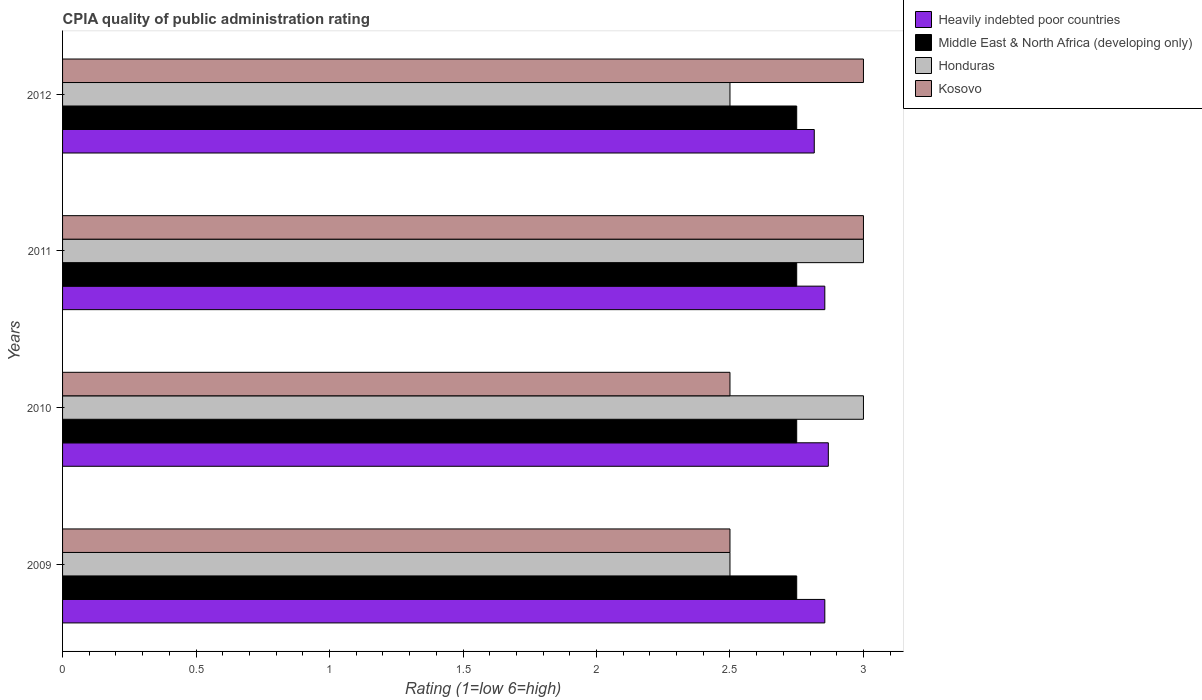What is the label of the 3rd group of bars from the top?
Provide a succinct answer. 2010. In how many cases, is the number of bars for a given year not equal to the number of legend labels?
Offer a terse response. 0. What is the CPIA rating in Kosovo in 2011?
Offer a terse response. 3. Across all years, what is the maximum CPIA rating in Heavily indebted poor countries?
Provide a succinct answer. 2.87. Across all years, what is the minimum CPIA rating in Heavily indebted poor countries?
Keep it short and to the point. 2.82. In which year was the CPIA rating in Honduras maximum?
Make the answer very short. 2010. In which year was the CPIA rating in Heavily indebted poor countries minimum?
Give a very brief answer. 2012. What is the total CPIA rating in Heavily indebted poor countries in the graph?
Ensure brevity in your answer.  11.39. What is the difference between the CPIA rating in Honduras in 2010 and the CPIA rating in Heavily indebted poor countries in 2012?
Your response must be concise. 0.18. What is the average CPIA rating in Heavily indebted poor countries per year?
Make the answer very short. 2.85. In the year 2012, what is the difference between the CPIA rating in Heavily indebted poor countries and CPIA rating in Kosovo?
Your answer should be very brief. -0.18. In how many years, is the CPIA rating in Kosovo greater than 1.6 ?
Offer a terse response. 4. What is the ratio of the CPIA rating in Middle East & North Africa (developing only) in 2009 to that in 2012?
Provide a succinct answer. 1. Is the CPIA rating in Middle East & North Africa (developing only) in 2009 less than that in 2011?
Give a very brief answer. No. What is the difference between the highest and the second highest CPIA rating in Honduras?
Provide a short and direct response. 0. What is the difference between the highest and the lowest CPIA rating in Middle East & North Africa (developing only)?
Offer a terse response. 0. What does the 4th bar from the top in 2010 represents?
Offer a terse response. Heavily indebted poor countries. What does the 3rd bar from the bottom in 2012 represents?
Provide a short and direct response. Honduras. Is it the case that in every year, the sum of the CPIA rating in Middle East & North Africa (developing only) and CPIA rating in Honduras is greater than the CPIA rating in Heavily indebted poor countries?
Make the answer very short. Yes. How many bars are there?
Provide a succinct answer. 16. Are all the bars in the graph horizontal?
Your answer should be very brief. Yes. Are the values on the major ticks of X-axis written in scientific E-notation?
Keep it short and to the point. No. Does the graph contain any zero values?
Make the answer very short. No. Does the graph contain grids?
Offer a terse response. No. How are the legend labels stacked?
Give a very brief answer. Vertical. What is the title of the graph?
Your answer should be very brief. CPIA quality of public administration rating. Does "Timor-Leste" appear as one of the legend labels in the graph?
Keep it short and to the point. No. What is the label or title of the X-axis?
Provide a short and direct response. Rating (1=low 6=high). What is the label or title of the Y-axis?
Provide a short and direct response. Years. What is the Rating (1=low 6=high) of Heavily indebted poor countries in 2009?
Provide a short and direct response. 2.86. What is the Rating (1=low 6=high) of Middle East & North Africa (developing only) in 2009?
Provide a succinct answer. 2.75. What is the Rating (1=low 6=high) of Honduras in 2009?
Give a very brief answer. 2.5. What is the Rating (1=low 6=high) of Kosovo in 2009?
Keep it short and to the point. 2.5. What is the Rating (1=low 6=high) of Heavily indebted poor countries in 2010?
Make the answer very short. 2.87. What is the Rating (1=low 6=high) of Middle East & North Africa (developing only) in 2010?
Offer a terse response. 2.75. What is the Rating (1=low 6=high) in Honduras in 2010?
Your answer should be very brief. 3. What is the Rating (1=low 6=high) in Kosovo in 2010?
Your answer should be very brief. 2.5. What is the Rating (1=low 6=high) in Heavily indebted poor countries in 2011?
Keep it short and to the point. 2.86. What is the Rating (1=low 6=high) in Middle East & North Africa (developing only) in 2011?
Make the answer very short. 2.75. What is the Rating (1=low 6=high) of Kosovo in 2011?
Give a very brief answer. 3. What is the Rating (1=low 6=high) in Heavily indebted poor countries in 2012?
Your response must be concise. 2.82. What is the Rating (1=low 6=high) in Middle East & North Africa (developing only) in 2012?
Ensure brevity in your answer.  2.75. What is the Rating (1=low 6=high) of Kosovo in 2012?
Give a very brief answer. 3. Across all years, what is the maximum Rating (1=low 6=high) in Heavily indebted poor countries?
Provide a short and direct response. 2.87. Across all years, what is the maximum Rating (1=low 6=high) in Middle East & North Africa (developing only)?
Provide a short and direct response. 2.75. Across all years, what is the minimum Rating (1=low 6=high) in Heavily indebted poor countries?
Your answer should be compact. 2.82. Across all years, what is the minimum Rating (1=low 6=high) of Middle East & North Africa (developing only)?
Provide a succinct answer. 2.75. Across all years, what is the minimum Rating (1=low 6=high) in Honduras?
Your response must be concise. 2.5. What is the total Rating (1=low 6=high) of Heavily indebted poor countries in the graph?
Your answer should be very brief. 11.39. What is the total Rating (1=low 6=high) of Middle East & North Africa (developing only) in the graph?
Your answer should be compact. 11. What is the total Rating (1=low 6=high) of Honduras in the graph?
Provide a short and direct response. 11. What is the total Rating (1=low 6=high) in Kosovo in the graph?
Offer a terse response. 11. What is the difference between the Rating (1=low 6=high) of Heavily indebted poor countries in 2009 and that in 2010?
Your answer should be compact. -0.01. What is the difference between the Rating (1=low 6=high) of Middle East & North Africa (developing only) in 2009 and that in 2010?
Offer a terse response. 0. What is the difference between the Rating (1=low 6=high) of Honduras in 2009 and that in 2010?
Make the answer very short. -0.5. What is the difference between the Rating (1=low 6=high) in Kosovo in 2009 and that in 2010?
Provide a short and direct response. 0. What is the difference between the Rating (1=low 6=high) of Heavily indebted poor countries in 2009 and that in 2011?
Provide a succinct answer. 0. What is the difference between the Rating (1=low 6=high) in Middle East & North Africa (developing only) in 2009 and that in 2011?
Ensure brevity in your answer.  0. What is the difference between the Rating (1=low 6=high) of Honduras in 2009 and that in 2011?
Provide a succinct answer. -0.5. What is the difference between the Rating (1=low 6=high) of Heavily indebted poor countries in 2009 and that in 2012?
Ensure brevity in your answer.  0.04. What is the difference between the Rating (1=low 6=high) in Middle East & North Africa (developing only) in 2009 and that in 2012?
Ensure brevity in your answer.  0. What is the difference between the Rating (1=low 6=high) of Honduras in 2009 and that in 2012?
Your answer should be compact. 0. What is the difference between the Rating (1=low 6=high) in Heavily indebted poor countries in 2010 and that in 2011?
Offer a very short reply. 0.01. What is the difference between the Rating (1=low 6=high) of Middle East & North Africa (developing only) in 2010 and that in 2011?
Your answer should be very brief. 0. What is the difference between the Rating (1=low 6=high) of Honduras in 2010 and that in 2011?
Provide a succinct answer. 0. What is the difference between the Rating (1=low 6=high) of Heavily indebted poor countries in 2010 and that in 2012?
Make the answer very short. 0.05. What is the difference between the Rating (1=low 6=high) in Kosovo in 2010 and that in 2012?
Your response must be concise. -0.5. What is the difference between the Rating (1=low 6=high) in Heavily indebted poor countries in 2011 and that in 2012?
Give a very brief answer. 0.04. What is the difference between the Rating (1=low 6=high) of Kosovo in 2011 and that in 2012?
Give a very brief answer. 0. What is the difference between the Rating (1=low 6=high) of Heavily indebted poor countries in 2009 and the Rating (1=low 6=high) of Middle East & North Africa (developing only) in 2010?
Offer a terse response. 0.11. What is the difference between the Rating (1=low 6=high) of Heavily indebted poor countries in 2009 and the Rating (1=low 6=high) of Honduras in 2010?
Make the answer very short. -0.14. What is the difference between the Rating (1=low 6=high) of Heavily indebted poor countries in 2009 and the Rating (1=low 6=high) of Kosovo in 2010?
Offer a terse response. 0.36. What is the difference between the Rating (1=low 6=high) of Middle East & North Africa (developing only) in 2009 and the Rating (1=low 6=high) of Honduras in 2010?
Your response must be concise. -0.25. What is the difference between the Rating (1=low 6=high) of Middle East & North Africa (developing only) in 2009 and the Rating (1=low 6=high) of Kosovo in 2010?
Make the answer very short. 0.25. What is the difference between the Rating (1=low 6=high) of Honduras in 2009 and the Rating (1=low 6=high) of Kosovo in 2010?
Ensure brevity in your answer.  0. What is the difference between the Rating (1=low 6=high) of Heavily indebted poor countries in 2009 and the Rating (1=low 6=high) of Middle East & North Africa (developing only) in 2011?
Provide a short and direct response. 0.11. What is the difference between the Rating (1=low 6=high) in Heavily indebted poor countries in 2009 and the Rating (1=low 6=high) in Honduras in 2011?
Offer a very short reply. -0.14. What is the difference between the Rating (1=low 6=high) in Heavily indebted poor countries in 2009 and the Rating (1=low 6=high) in Kosovo in 2011?
Provide a succinct answer. -0.14. What is the difference between the Rating (1=low 6=high) in Honduras in 2009 and the Rating (1=low 6=high) in Kosovo in 2011?
Keep it short and to the point. -0.5. What is the difference between the Rating (1=low 6=high) in Heavily indebted poor countries in 2009 and the Rating (1=low 6=high) in Middle East & North Africa (developing only) in 2012?
Give a very brief answer. 0.11. What is the difference between the Rating (1=low 6=high) of Heavily indebted poor countries in 2009 and the Rating (1=low 6=high) of Honduras in 2012?
Provide a succinct answer. 0.36. What is the difference between the Rating (1=low 6=high) in Heavily indebted poor countries in 2009 and the Rating (1=low 6=high) in Kosovo in 2012?
Keep it short and to the point. -0.14. What is the difference between the Rating (1=low 6=high) of Middle East & North Africa (developing only) in 2009 and the Rating (1=low 6=high) of Kosovo in 2012?
Offer a terse response. -0.25. What is the difference between the Rating (1=low 6=high) in Honduras in 2009 and the Rating (1=low 6=high) in Kosovo in 2012?
Provide a succinct answer. -0.5. What is the difference between the Rating (1=low 6=high) in Heavily indebted poor countries in 2010 and the Rating (1=low 6=high) in Middle East & North Africa (developing only) in 2011?
Offer a terse response. 0.12. What is the difference between the Rating (1=low 6=high) of Heavily indebted poor countries in 2010 and the Rating (1=low 6=high) of Honduras in 2011?
Give a very brief answer. -0.13. What is the difference between the Rating (1=low 6=high) in Heavily indebted poor countries in 2010 and the Rating (1=low 6=high) in Kosovo in 2011?
Keep it short and to the point. -0.13. What is the difference between the Rating (1=low 6=high) in Middle East & North Africa (developing only) in 2010 and the Rating (1=low 6=high) in Honduras in 2011?
Offer a terse response. -0.25. What is the difference between the Rating (1=low 6=high) of Honduras in 2010 and the Rating (1=low 6=high) of Kosovo in 2011?
Offer a very short reply. 0. What is the difference between the Rating (1=low 6=high) in Heavily indebted poor countries in 2010 and the Rating (1=low 6=high) in Middle East & North Africa (developing only) in 2012?
Offer a very short reply. 0.12. What is the difference between the Rating (1=low 6=high) of Heavily indebted poor countries in 2010 and the Rating (1=low 6=high) of Honduras in 2012?
Keep it short and to the point. 0.37. What is the difference between the Rating (1=low 6=high) of Heavily indebted poor countries in 2010 and the Rating (1=low 6=high) of Kosovo in 2012?
Give a very brief answer. -0.13. What is the difference between the Rating (1=low 6=high) of Middle East & North Africa (developing only) in 2010 and the Rating (1=low 6=high) of Honduras in 2012?
Make the answer very short. 0.25. What is the difference between the Rating (1=low 6=high) in Middle East & North Africa (developing only) in 2010 and the Rating (1=low 6=high) in Kosovo in 2012?
Keep it short and to the point. -0.25. What is the difference between the Rating (1=low 6=high) in Heavily indebted poor countries in 2011 and the Rating (1=low 6=high) in Middle East & North Africa (developing only) in 2012?
Your answer should be compact. 0.11. What is the difference between the Rating (1=low 6=high) of Heavily indebted poor countries in 2011 and the Rating (1=low 6=high) of Honduras in 2012?
Your answer should be compact. 0.36. What is the difference between the Rating (1=low 6=high) in Heavily indebted poor countries in 2011 and the Rating (1=low 6=high) in Kosovo in 2012?
Your answer should be very brief. -0.14. What is the difference between the Rating (1=low 6=high) of Middle East & North Africa (developing only) in 2011 and the Rating (1=low 6=high) of Honduras in 2012?
Give a very brief answer. 0.25. What is the difference between the Rating (1=low 6=high) of Middle East & North Africa (developing only) in 2011 and the Rating (1=low 6=high) of Kosovo in 2012?
Offer a very short reply. -0.25. What is the average Rating (1=low 6=high) in Heavily indebted poor countries per year?
Offer a very short reply. 2.85. What is the average Rating (1=low 6=high) in Middle East & North Africa (developing only) per year?
Your answer should be very brief. 2.75. What is the average Rating (1=low 6=high) in Honduras per year?
Your response must be concise. 2.75. What is the average Rating (1=low 6=high) of Kosovo per year?
Keep it short and to the point. 2.75. In the year 2009, what is the difference between the Rating (1=low 6=high) in Heavily indebted poor countries and Rating (1=low 6=high) in Middle East & North Africa (developing only)?
Give a very brief answer. 0.11. In the year 2009, what is the difference between the Rating (1=low 6=high) in Heavily indebted poor countries and Rating (1=low 6=high) in Honduras?
Provide a succinct answer. 0.36. In the year 2009, what is the difference between the Rating (1=low 6=high) of Heavily indebted poor countries and Rating (1=low 6=high) of Kosovo?
Make the answer very short. 0.36. In the year 2009, what is the difference between the Rating (1=low 6=high) in Middle East & North Africa (developing only) and Rating (1=low 6=high) in Kosovo?
Your answer should be very brief. 0.25. In the year 2009, what is the difference between the Rating (1=low 6=high) in Honduras and Rating (1=low 6=high) in Kosovo?
Give a very brief answer. 0. In the year 2010, what is the difference between the Rating (1=low 6=high) of Heavily indebted poor countries and Rating (1=low 6=high) of Middle East & North Africa (developing only)?
Ensure brevity in your answer.  0.12. In the year 2010, what is the difference between the Rating (1=low 6=high) of Heavily indebted poor countries and Rating (1=low 6=high) of Honduras?
Your response must be concise. -0.13. In the year 2010, what is the difference between the Rating (1=low 6=high) of Heavily indebted poor countries and Rating (1=low 6=high) of Kosovo?
Your answer should be compact. 0.37. In the year 2010, what is the difference between the Rating (1=low 6=high) of Middle East & North Africa (developing only) and Rating (1=low 6=high) of Kosovo?
Your answer should be compact. 0.25. In the year 2011, what is the difference between the Rating (1=low 6=high) in Heavily indebted poor countries and Rating (1=low 6=high) in Middle East & North Africa (developing only)?
Your answer should be compact. 0.11. In the year 2011, what is the difference between the Rating (1=low 6=high) in Heavily indebted poor countries and Rating (1=low 6=high) in Honduras?
Your answer should be compact. -0.14. In the year 2011, what is the difference between the Rating (1=low 6=high) of Heavily indebted poor countries and Rating (1=low 6=high) of Kosovo?
Make the answer very short. -0.14. In the year 2012, what is the difference between the Rating (1=low 6=high) in Heavily indebted poor countries and Rating (1=low 6=high) in Middle East & North Africa (developing only)?
Make the answer very short. 0.07. In the year 2012, what is the difference between the Rating (1=low 6=high) in Heavily indebted poor countries and Rating (1=low 6=high) in Honduras?
Keep it short and to the point. 0.32. In the year 2012, what is the difference between the Rating (1=low 6=high) of Heavily indebted poor countries and Rating (1=low 6=high) of Kosovo?
Provide a short and direct response. -0.18. In the year 2012, what is the difference between the Rating (1=low 6=high) of Middle East & North Africa (developing only) and Rating (1=low 6=high) of Honduras?
Provide a short and direct response. 0.25. In the year 2012, what is the difference between the Rating (1=low 6=high) of Middle East & North Africa (developing only) and Rating (1=low 6=high) of Kosovo?
Keep it short and to the point. -0.25. What is the ratio of the Rating (1=low 6=high) of Heavily indebted poor countries in 2009 to that in 2010?
Give a very brief answer. 1. What is the ratio of the Rating (1=low 6=high) of Middle East & North Africa (developing only) in 2009 to that in 2010?
Your response must be concise. 1. What is the ratio of the Rating (1=low 6=high) of Middle East & North Africa (developing only) in 2009 to that in 2011?
Make the answer very short. 1. What is the ratio of the Rating (1=low 6=high) in Heavily indebted poor countries in 2009 to that in 2012?
Your response must be concise. 1.01. What is the ratio of the Rating (1=low 6=high) of Middle East & North Africa (developing only) in 2009 to that in 2012?
Provide a succinct answer. 1. What is the ratio of the Rating (1=low 6=high) of Heavily indebted poor countries in 2010 to that in 2011?
Ensure brevity in your answer.  1. What is the ratio of the Rating (1=low 6=high) in Heavily indebted poor countries in 2010 to that in 2012?
Offer a terse response. 1.02. What is the ratio of the Rating (1=low 6=high) in Honduras in 2010 to that in 2012?
Offer a terse response. 1.2. What is the ratio of the Rating (1=low 6=high) of Heavily indebted poor countries in 2011 to that in 2012?
Provide a succinct answer. 1.01. What is the ratio of the Rating (1=low 6=high) in Kosovo in 2011 to that in 2012?
Offer a very short reply. 1. What is the difference between the highest and the second highest Rating (1=low 6=high) in Heavily indebted poor countries?
Make the answer very short. 0.01. What is the difference between the highest and the second highest Rating (1=low 6=high) of Middle East & North Africa (developing only)?
Make the answer very short. 0. What is the difference between the highest and the second highest Rating (1=low 6=high) of Honduras?
Provide a short and direct response. 0. What is the difference between the highest and the second highest Rating (1=low 6=high) in Kosovo?
Give a very brief answer. 0. What is the difference between the highest and the lowest Rating (1=low 6=high) of Heavily indebted poor countries?
Give a very brief answer. 0.05. What is the difference between the highest and the lowest Rating (1=low 6=high) in Middle East & North Africa (developing only)?
Provide a short and direct response. 0. What is the difference between the highest and the lowest Rating (1=low 6=high) of Honduras?
Give a very brief answer. 0.5. 